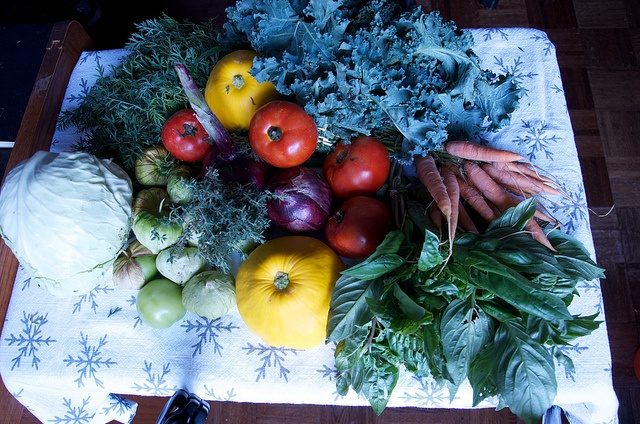Describe the objects in this image and their specific colors. I can see dining table in black, white, lightblue, and teal tones, carrot in black, lightpink, violet, and brown tones, carrot in black, violet, maroon, and brown tones, carrot in black, maroon, and purple tones, and carrot in black, brown, maroon, and purple tones in this image. 